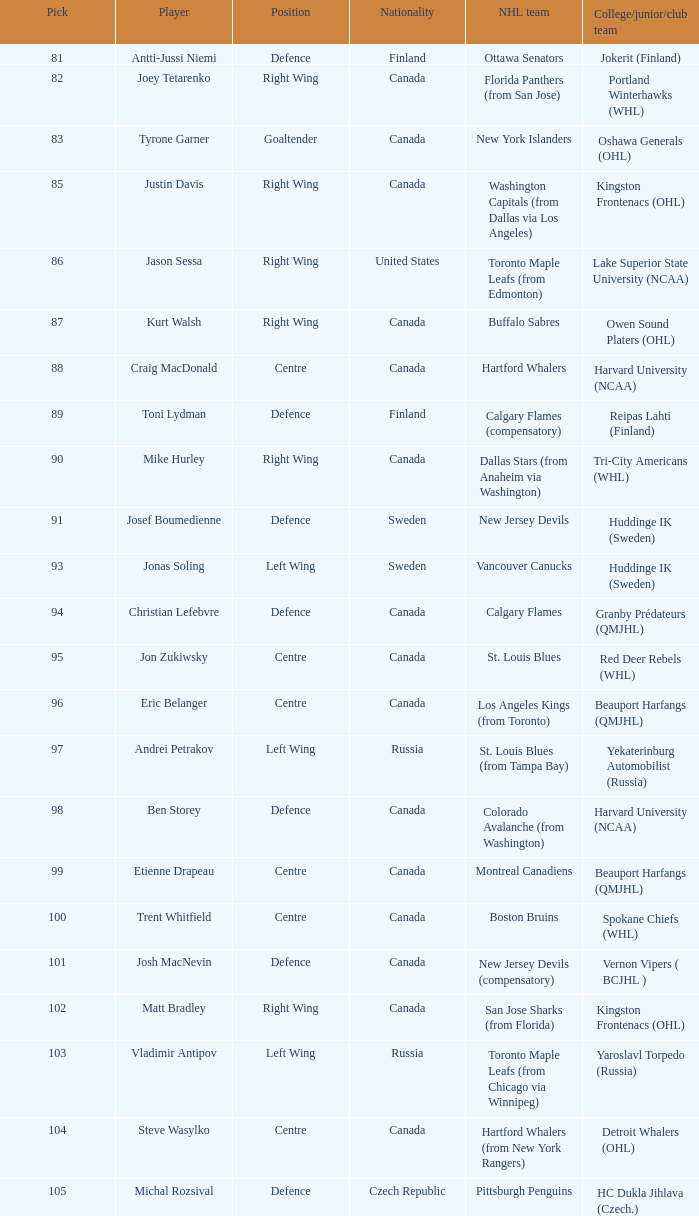What position does that draft pick play from Lake Superior State University (NCAA)? Right Wing. 